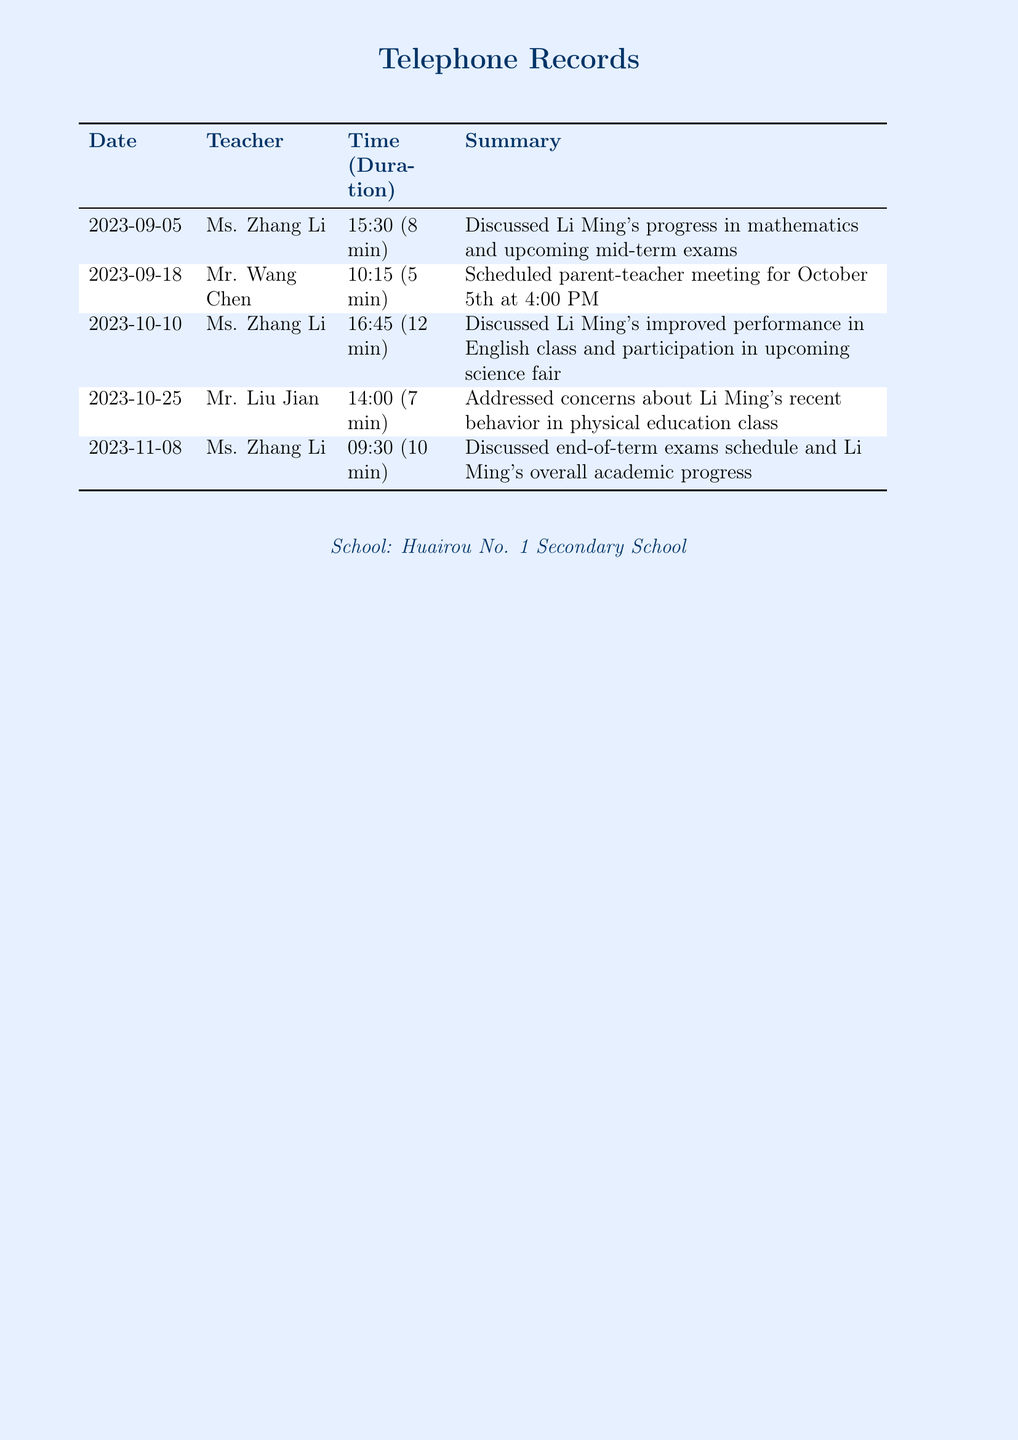What is the date of the scheduled parent-teacher meeting? The scheduled parent-teacher meeting is mentioned on 2023-09-18.
Answer: October 5th Who discussed Li Ming's performance in English? Ms. Zhang Li is mentioned as the teacher discussing Li Ming's performance in English.
Answer: Ms. Zhang Li How long was the call with Mr. Liu Jian? The call with Mr. Liu Jian lasted for 7 minutes, as indicated in the document.
Answer: 7 min Which subject had concerns addressed regarding Li Ming's behavior? The concerns were specifically about Li Ming's behavior in physical education class.
Answer: Physical education What was discussed during the call on November 8th? The call on November 8th discussed end-of-term exams schedule and Li Ming's overall academic progress.
Answer: End-of-term exams schedule How many calls were made to Ms. Zhang Li? The document lists two calls made to Ms. Zhang Li.
Answer: 2 When was the first call made in the record? The first call date in the record is on 2023-09-05.
Answer: 2023-09-05 Who scheduled the parent-teacher meeting? Mr. Wang Chen is the teacher who scheduled the meeting.
Answer: Mr. Wang Chen 